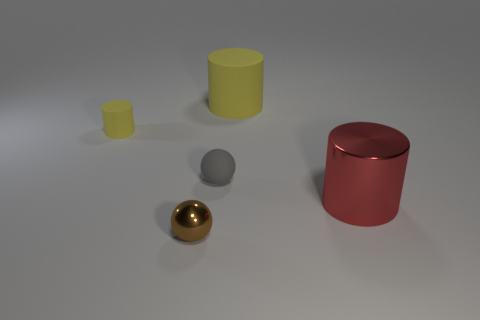Are the large object in front of the small yellow object and the cylinder on the left side of the rubber sphere made of the same material?
Ensure brevity in your answer.  No. Is the number of gray rubber things left of the small gray matte ball the same as the number of tiny balls in front of the large red metallic object?
Keep it short and to the point. No. There is a metal thing that is the same size as the gray rubber ball; what is its color?
Offer a very short reply. Brown. Is there another tiny metal sphere that has the same color as the shiny ball?
Offer a terse response. No. How many things are either tiny brown things that are in front of the big yellow rubber cylinder or tiny yellow things?
Offer a very short reply. 2. How many other objects are the same size as the red metal cylinder?
Ensure brevity in your answer.  1. There is a big thing behind the small matte thing that is to the left of the tiny sphere in front of the matte ball; what is it made of?
Provide a succinct answer. Rubber. What number of balls are big shiny things or small brown things?
Offer a terse response. 1. Is there anything else that is the same shape as the large matte object?
Offer a terse response. Yes. Are there more tiny things on the right side of the tiny gray thing than yellow objects that are on the right side of the brown ball?
Ensure brevity in your answer.  No. 